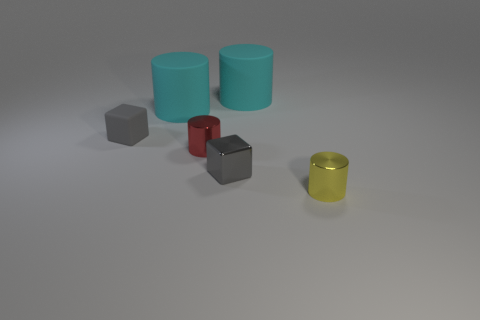What is the material of the small gray cube that is in front of the tiny gray matte cube?
Provide a succinct answer. Metal. Is there any other thing that has the same shape as the gray metallic object?
Ensure brevity in your answer.  Yes. How many shiny objects are yellow things or small blue things?
Ensure brevity in your answer.  1. Is the number of tiny matte cubes that are in front of the tiny metallic block less than the number of big metallic cubes?
Make the answer very short. No. What is the shape of the tiny object that is to the right of the cube in front of the metallic cylinder behind the small yellow metal cylinder?
Offer a very short reply. Cylinder. Do the tiny matte cube and the metal block have the same color?
Offer a terse response. Yes. Is the number of small yellow cylinders greater than the number of large cyan rubber cylinders?
Offer a terse response. No. How many other things are the same material as the yellow cylinder?
Your response must be concise. 2. How many objects are either tiny things or big cyan matte cylinders that are on the right side of the tiny red cylinder?
Your answer should be compact. 5. Is the number of yellow metal cylinders less than the number of green spheres?
Offer a terse response. No. 